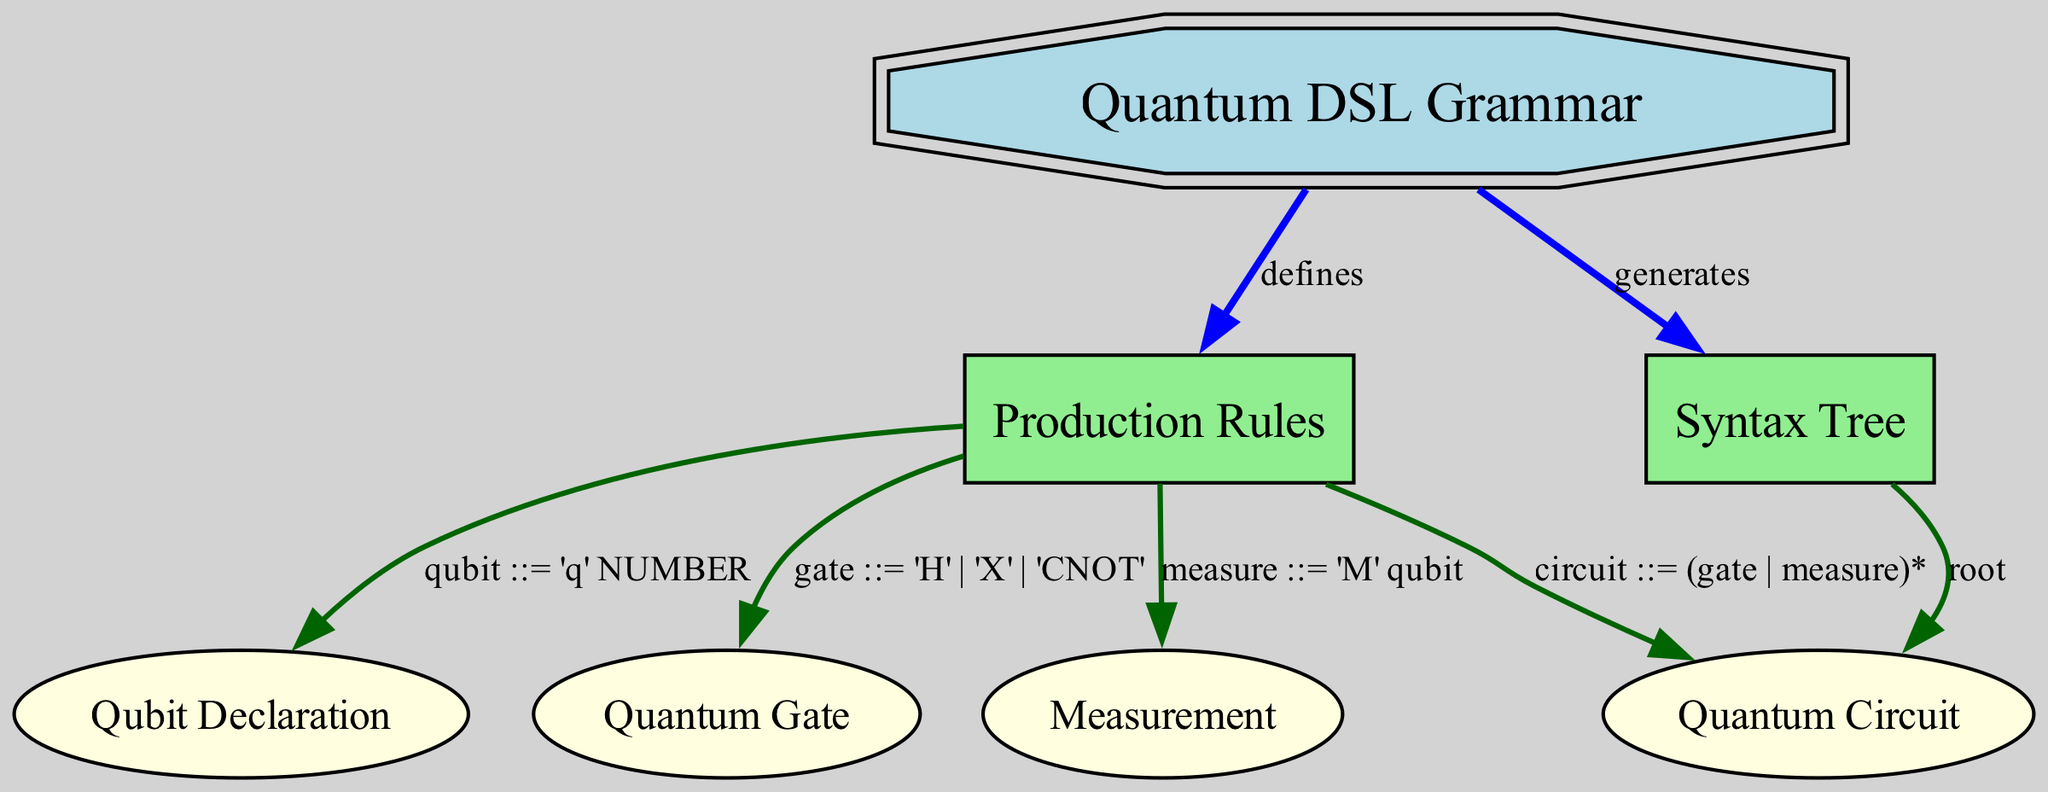What is the root node of the syntax tree? The root node of the syntax tree is indicated by the edge from the "Syntax Tree" node leading to the "Quantum Circuit" node labeled as "root". Hence, the "Quantum Circuit" is the top-level structure in the syntax tree.
Answer: Quantum Circuit How many nodes are in the diagram? To find the number of nodes, we count all the unique nodes listed in the "nodes" array: "Quantum DSL Grammar", "Production Rules", "Syntax Tree", "Qubit Declaration", "Quantum Gate", "Measurement", and "Quantum Circuit". This results in a total of 7 nodes.
Answer: 7 What does the production rule for a qubit declare? The production rule describing a qubit is represented in the edge connecting "Production Rules" and "Qubit Declaration", labeled "qubit ::= 'q' NUMBER", which specifies the exact syntax for declaring a qubit in this DSL.
Answer: 'q' NUMBER Which node is connected to the "Production Rules" node by an edge that defines a circuit? The node connected to the "Production Rules" node that describes a circuit is the "Quantum Circuit". The edge specifies that a circuit can consist of any combination of gates or measurements as indicated by the corresponding production rule.
Answer: Quantum Circuit What type of relationship exists between "Quantum DSL Grammar" and "Production Rules"? The relationship between "Quantum DSL Grammar" and "Production Rules" is defined as "defines", as indicated by the directed edge from "Quantum DSL Grammar" to "Production Rules". This suggests that the quantum DSL grammar specifies the production rules for its expressions.
Answer: defines Which production rule involves measurement in the grammar? The production rule that involves measurement is shown as "measure ::= 'M' qubit". This is represented in the edge from "Production Rules" to "Measurement". It indicates how a measurement can be expressed in this quantum DSL.
Answer: 'M' qubit How many edges are there in total connecting nodes in the diagram? To determine the total number of edges, we count each connection defined in the "edges" array. There are 7 edges listed that indicate relationships between nodes, so the total number is 7.
Answer: 7 Which node represents the declaration of qubits? The node representing the declaration of qubits is "Qubit Declaration". This is explicitly stated in the diagram where the qubit production rule is connected to this node, indicating its role in the grammar.
Answer: Qubit Declaration 